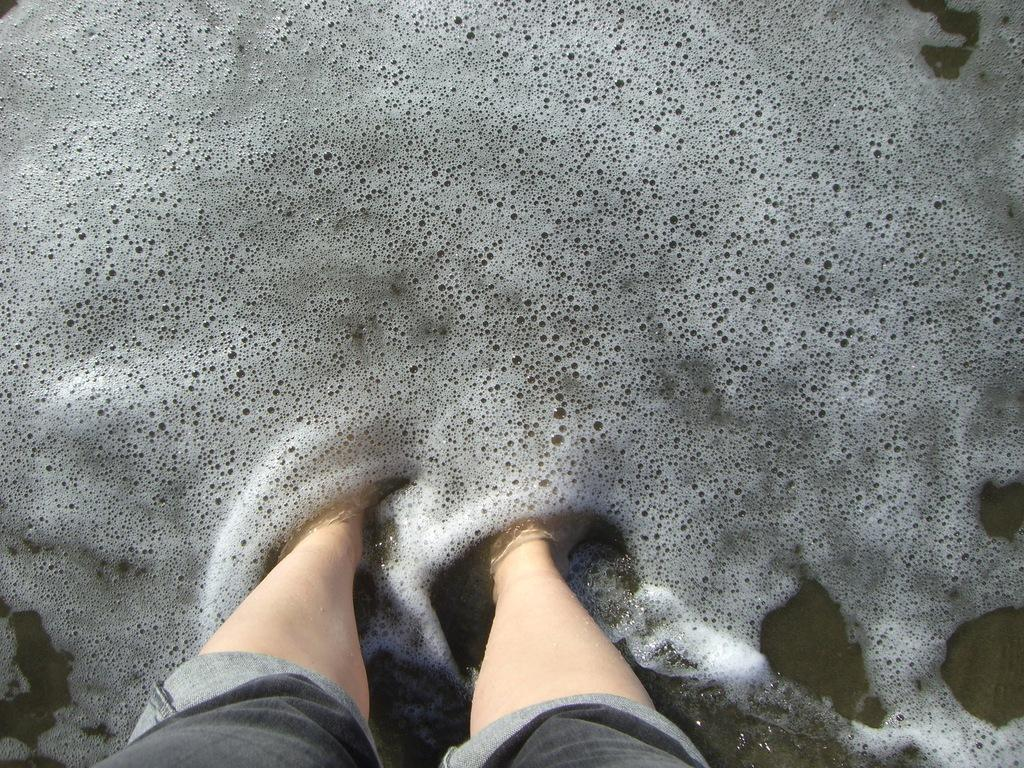What is partially submerged in the water in the image? There are legs of a person visible in the water in the image. Can you describe the position of the legs in the water? The legs are partially submerged in the water. What type of pickle is floating next to the person's legs in the image? There is no pickle present in the image; only the legs of a person are visible in the water. 